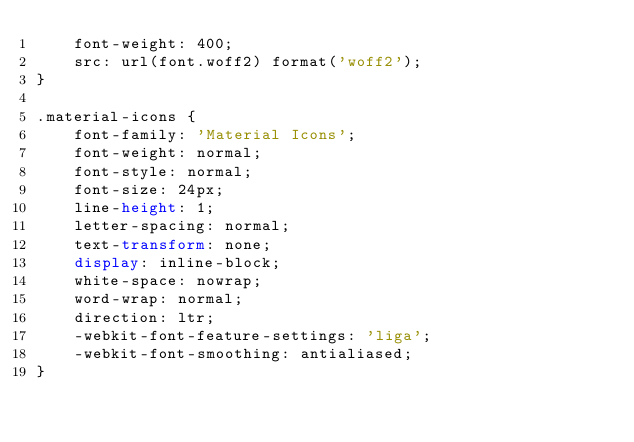Convert code to text. <code><loc_0><loc_0><loc_500><loc_500><_CSS_>    font-weight: 400;
    src: url(font.woff2) format('woff2');
}

.material-icons {
    font-family: 'Material Icons';
    font-weight: normal;
    font-style: normal;
    font-size: 24px;
    line-height: 1;
    letter-spacing: normal;
    text-transform: none;
    display: inline-block;
    white-space: nowrap;
    word-wrap: normal;
    direction: ltr;
    -webkit-font-feature-settings: 'liga';
    -webkit-font-smoothing: antialiased;
}
</code> 